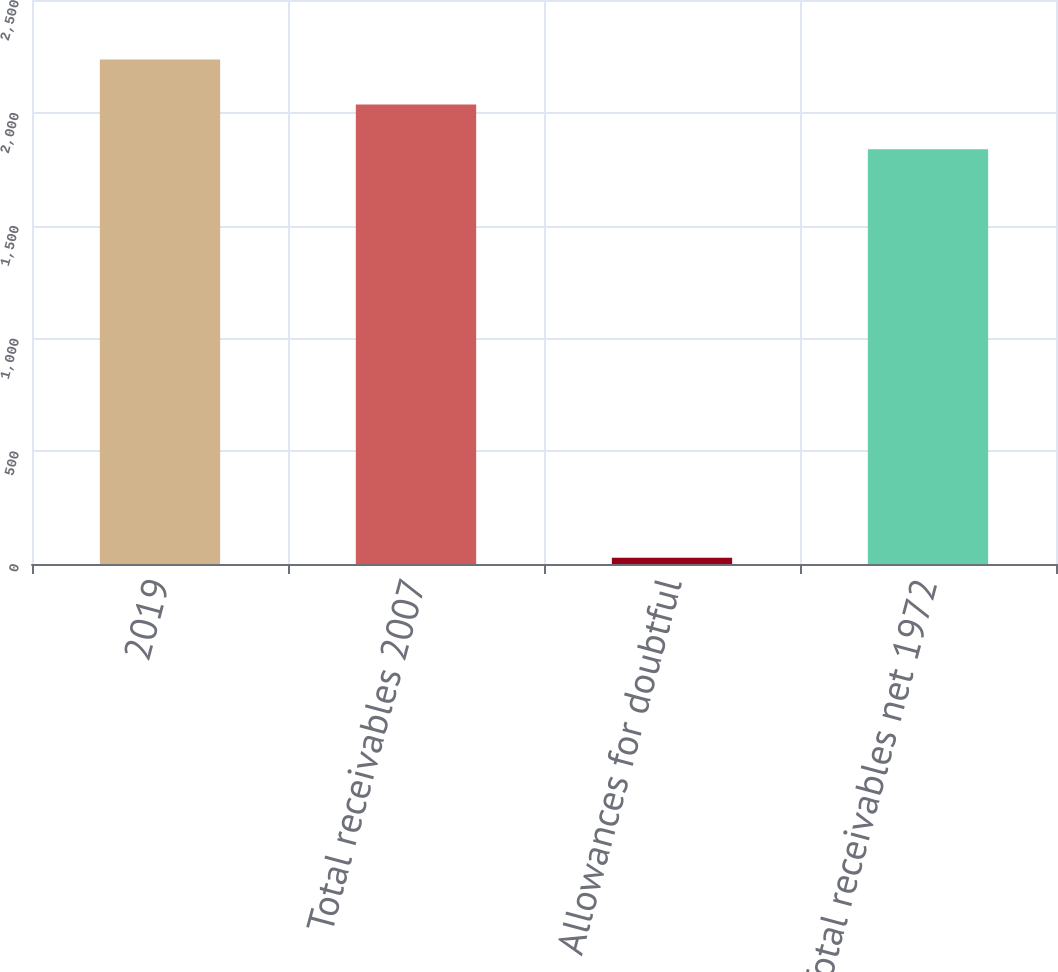Convert chart to OTSL. <chart><loc_0><loc_0><loc_500><loc_500><bar_chart><fcel>2019<fcel>Total receivables 2007<fcel>Allowances for doubtful<fcel>Total receivables net 1972<nl><fcel>2236<fcel>2037<fcel>28<fcel>1838<nl></chart> 